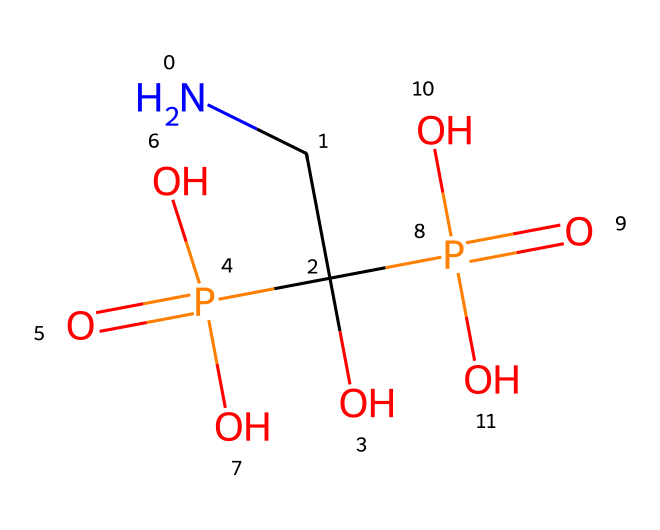What is the formula of alendronic acid? The SMILES representation indicates the atomic composition. By analyzing the SMILES, we identify one nitrogen (N), four carbons (C), four oxygens (O), and two phosphorous (P) atoms, giving us a molecular formula of C4H11N2O7P2.
Answer: C4H11N2O7P2 How many phosphorus atoms are present in this compound? The SMILES representation shows the presence of the letter "P" twice, indicating that there are two phosphorus atoms in the structure of alendronic acid.
Answer: 2 What functional groups are present in alendronic acid? In the SMILES, we can spot hydroxyl groups (the "O" attached to "-C" and the other atoms), phosphate groups (the presence of "P(=O)"), and amine (the presence of "N"). These indicate the functional groups in the structure.
Answer: hydroxyl, phosphate, amine Does alendronic acid have any chiral centers? To determine chirality, we look for carbon atoms bonded to four different substituents. In the structure derived from the SMILES, one of the carbon atoms is bonded to multiple identical groups (O and P), indicating it is not a chiral center.
Answer: no What type of chemical bond connects the phosphorus atom to the oxygen in alendronic acid? The connections between phosphorus and oxygen (as seen in the SMILES) exhibit double and single bond characteristics, commonly seen in phosphate groups. The "P(=O)" notation reflects a double bond, while P-O from "P(=O)(O)" indicates a single bond.
Answer: single and double bonds How does alendronic acid act as a bisphosphonate? The presence of two phosphonate groups (the P(=O)(O)O) makes it a bisphosphonate. The structure's two phosphorus atoms interact with bone mineral, inhibiting osteoclast activity and reducing bone resorption.
Answer: inhibits osteoclast activity 